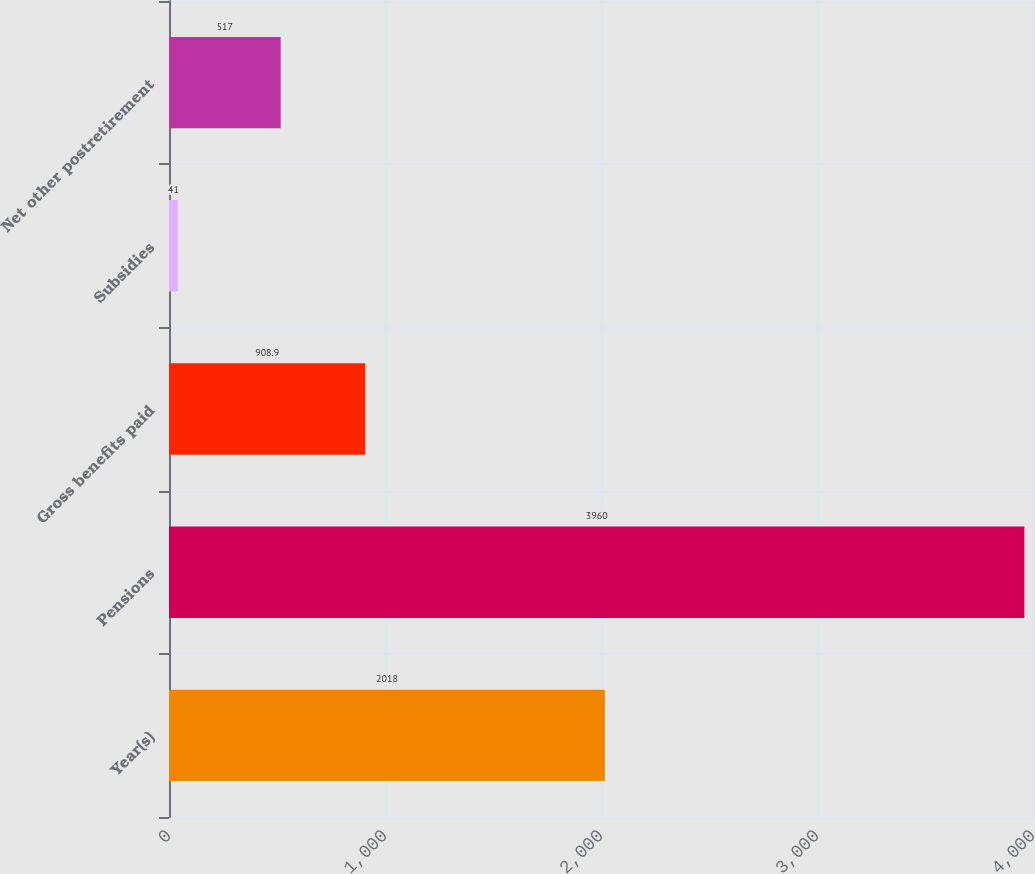Convert chart to OTSL. <chart><loc_0><loc_0><loc_500><loc_500><bar_chart><fcel>Year(s)<fcel>Pensions<fcel>Gross benefits paid<fcel>Subsidies<fcel>Net other postretirement<nl><fcel>2018<fcel>3960<fcel>908.9<fcel>41<fcel>517<nl></chart> 